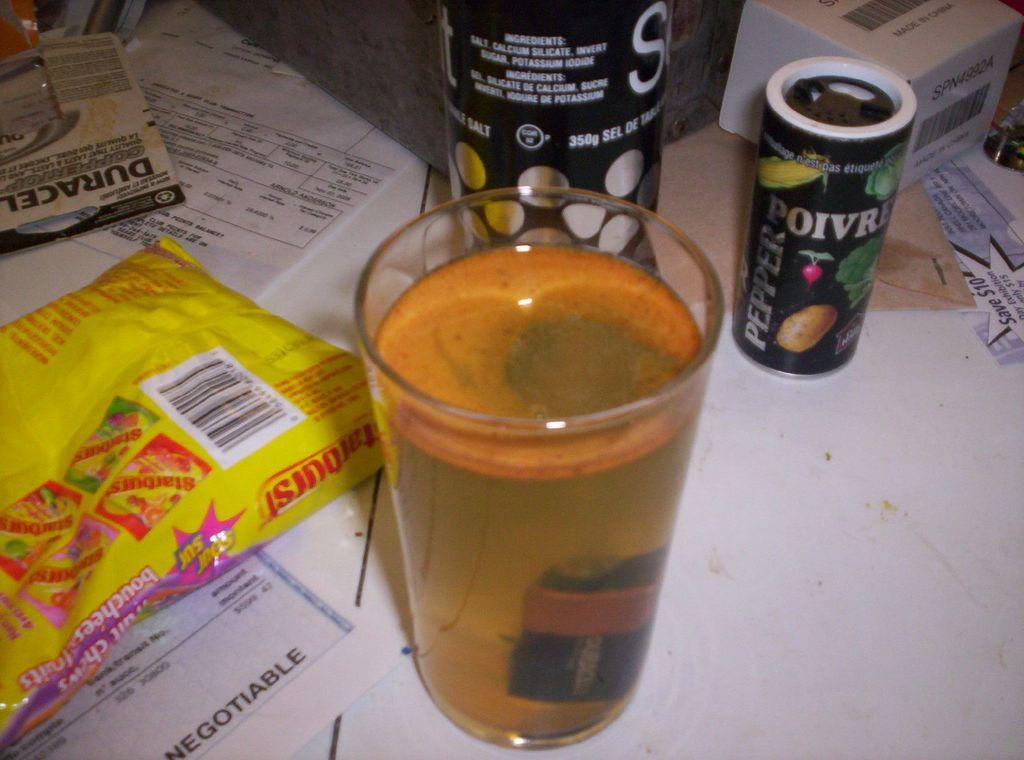<image>
Provide a brief description of the given image. A cup of murky water with a Duracell D battery at the bottom of it. 